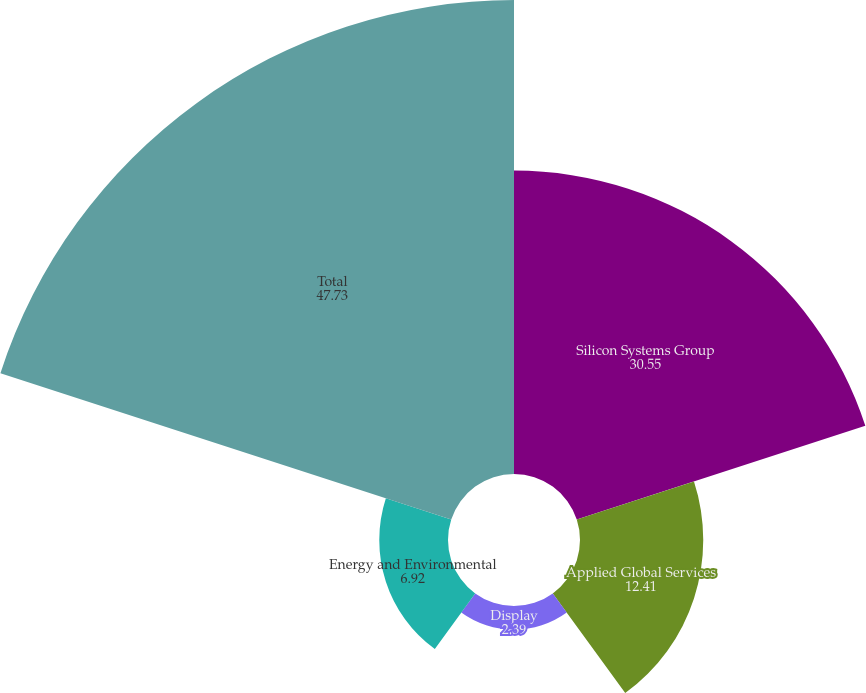Convert chart. <chart><loc_0><loc_0><loc_500><loc_500><pie_chart><fcel>Silicon Systems Group<fcel>Applied Global Services<fcel>Display<fcel>Energy and Environmental<fcel>Total<nl><fcel>30.55%<fcel>12.41%<fcel>2.39%<fcel>6.92%<fcel>47.73%<nl></chart> 